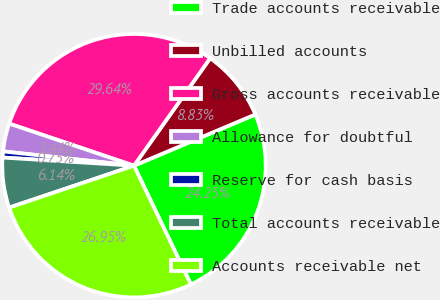<chart> <loc_0><loc_0><loc_500><loc_500><pie_chart><fcel>Trade accounts receivable<fcel>Unbilled accounts<fcel>Gross accounts receivable<fcel>Allowance for doubtful<fcel>Reserve for cash basis<fcel>Total accounts receivable<fcel>Accounts receivable net<nl><fcel>24.25%<fcel>8.83%<fcel>29.64%<fcel>3.44%<fcel>0.75%<fcel>6.14%<fcel>26.95%<nl></chart> 